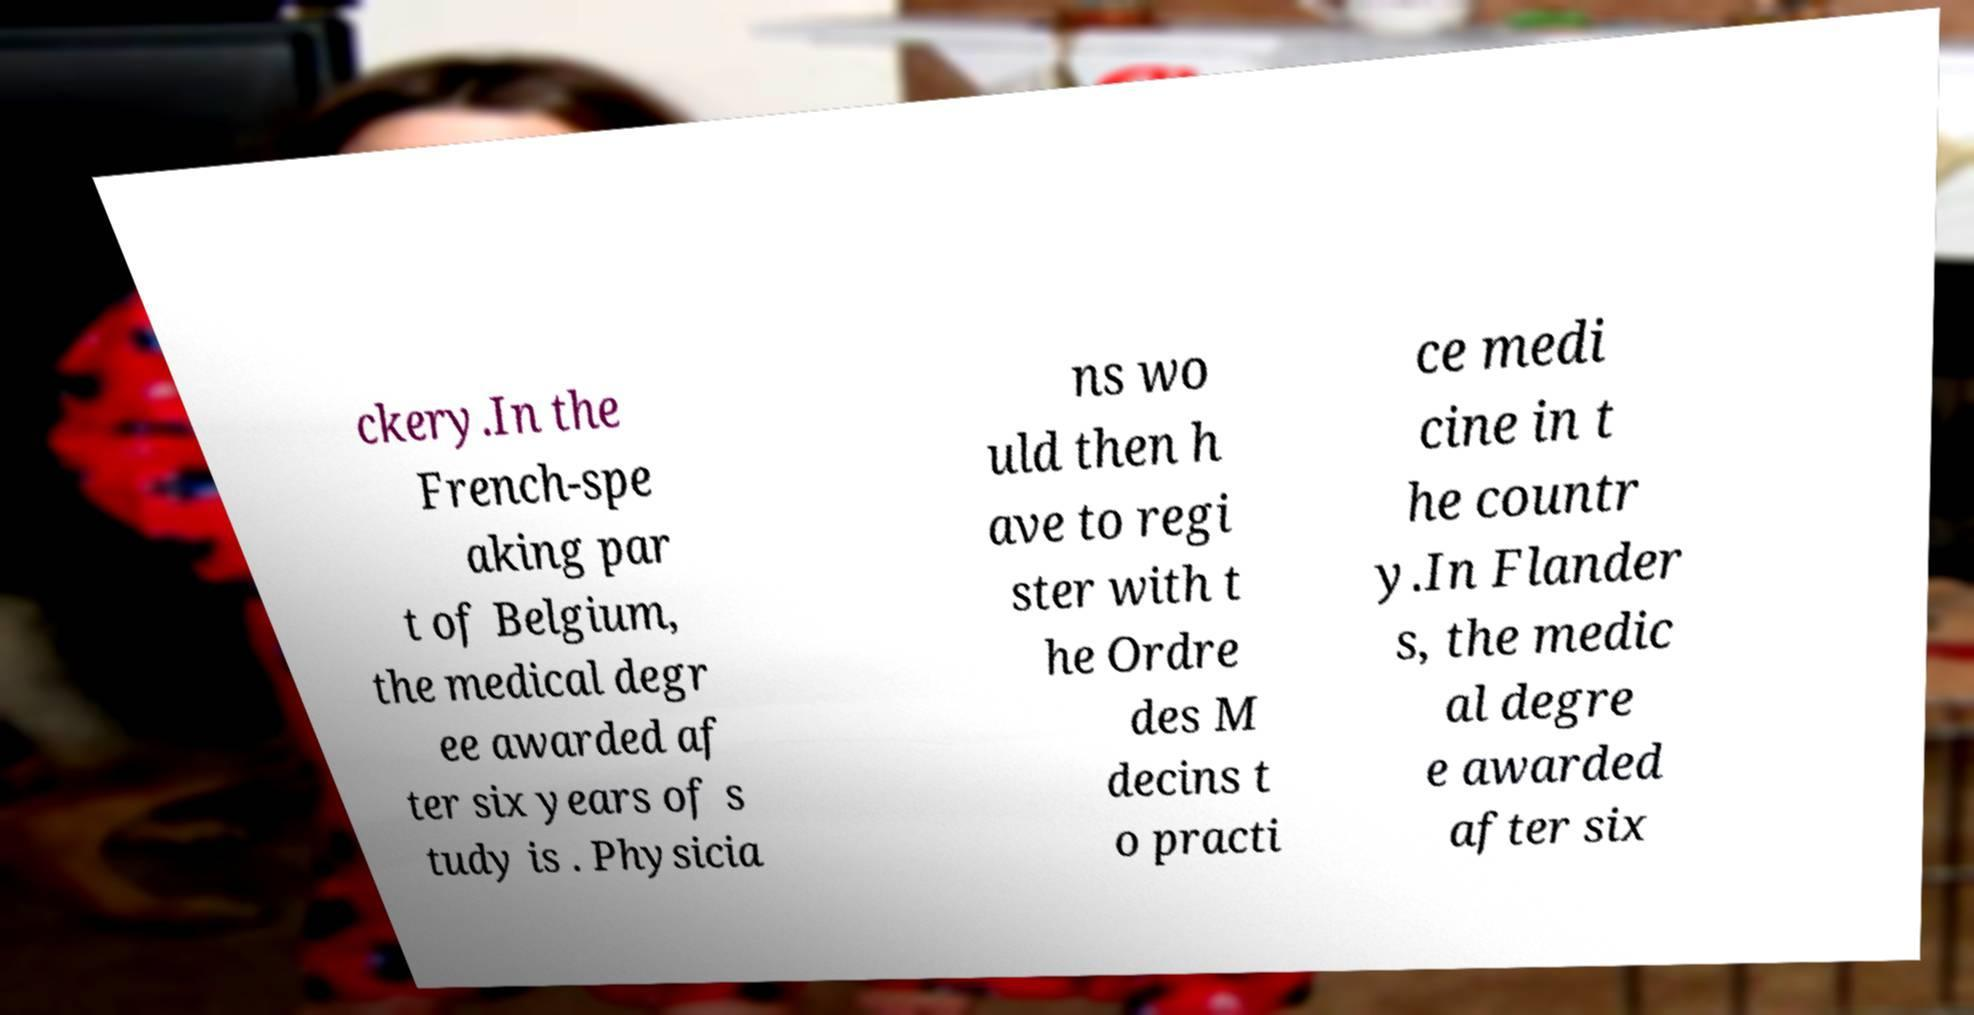Can you read and provide the text displayed in the image?This photo seems to have some interesting text. Can you extract and type it out for me? ckery.In the French-spe aking par t of Belgium, the medical degr ee awarded af ter six years of s tudy is . Physicia ns wo uld then h ave to regi ster with t he Ordre des M decins t o practi ce medi cine in t he countr y.In Flander s, the medic al degre e awarded after six 